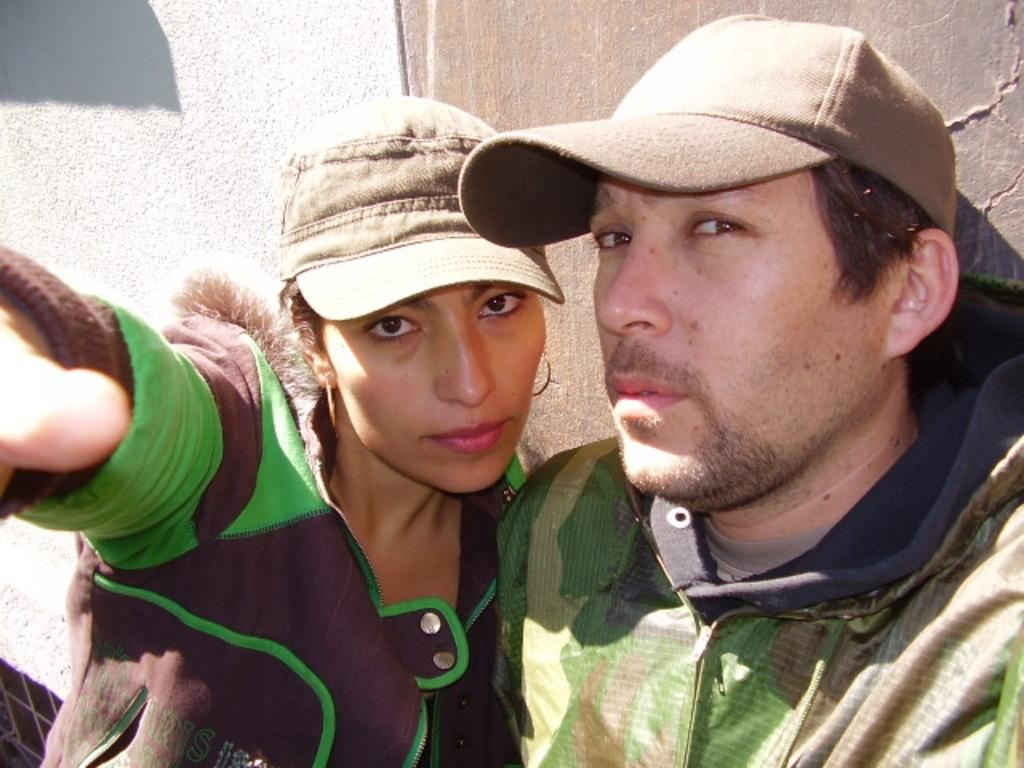What is the gender of the person on the left side of the image? There is a woman on the left side of the image. What is the gender of the person on the right side of the image? There is: There is a man on the right side of the image. What are the people in the image wearing on their heads? Both the woman and the man are wearing caps. What can be seen in the background of the image? There is a wall visible in the background of the image. We start by identifying the two main subjects in the image, which are the woman and the man. Then, we describe their headwear, which is the same for both individuals. Finally, we mention the background element, which is the wall. How does the woman compare her brother's shop to the one in the image? There is no mention of a brother or a shop in the image, so it is not possible to answer this question. 